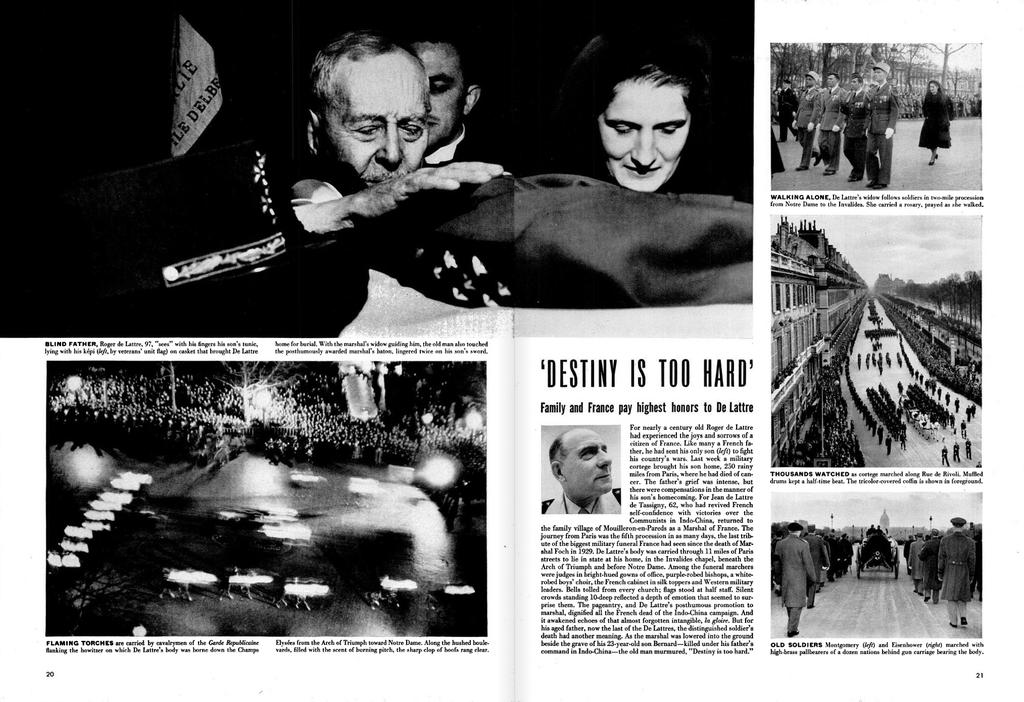What type of artwork is depicted in the image? The image is a collage. What color scheme is used in the collage? The collage is black and white. What elements can be found in the collage? There is text and images present in the collage. Can you see the moon in the collage? There is no moon visible in the collage. 